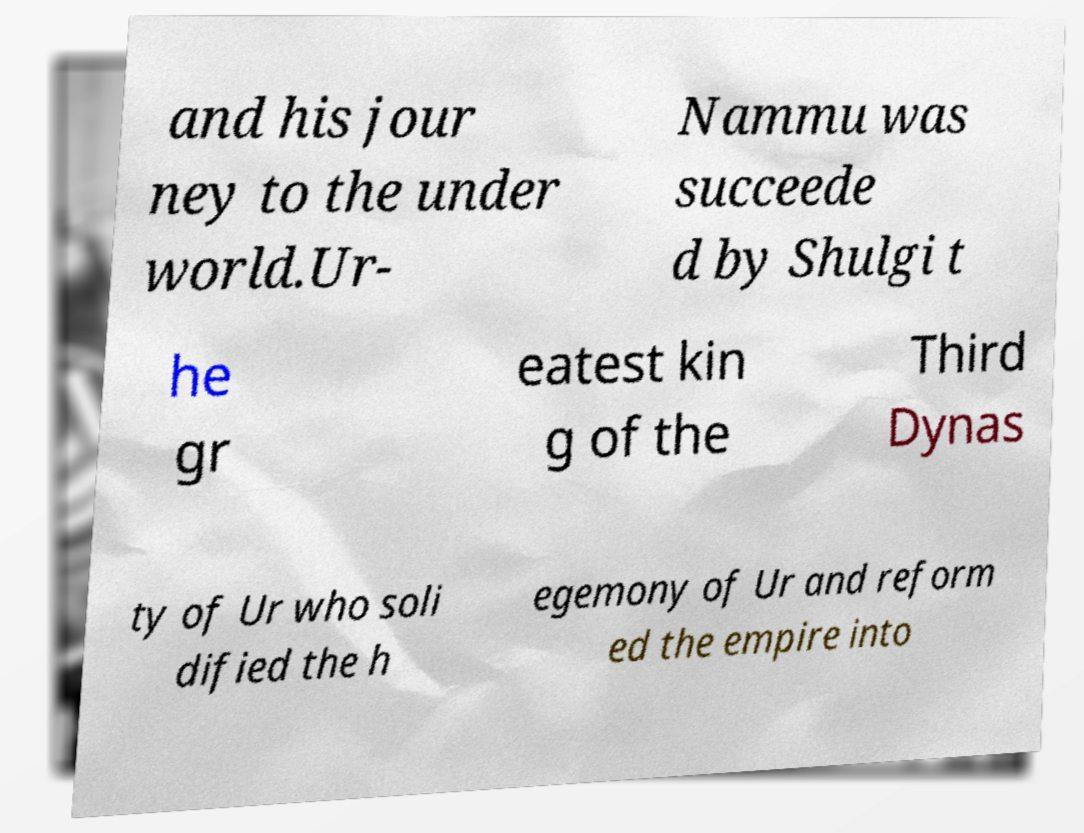What messages or text are displayed in this image? I need them in a readable, typed format. and his jour ney to the under world.Ur- Nammu was succeede d by Shulgi t he gr eatest kin g of the Third Dynas ty of Ur who soli dified the h egemony of Ur and reform ed the empire into 